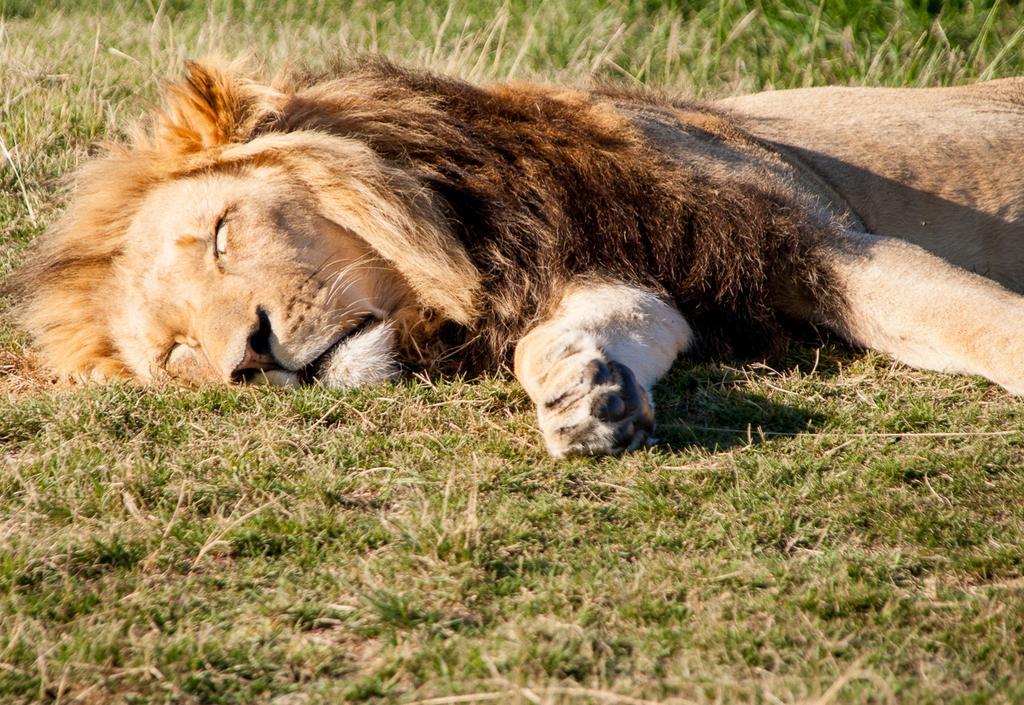How would you summarize this image in a sentence or two? In this image we can see a lion. At the bottom there is grass. 